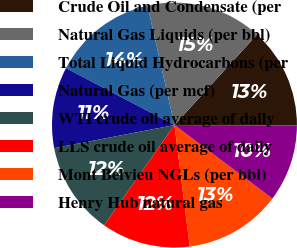<chart> <loc_0><loc_0><loc_500><loc_500><pie_chart><fcel>Crude Oil and Condensate (per<fcel>Natural Gas Liquids (per bbl)<fcel>Total Liquid Hydrocarbons (per<fcel>Natural Gas (per mcf)<fcel>WTI crude oil average of daily<fcel>LLS crude oil average of daily<fcel>Mont Belvieu NGLs (per bbl)<fcel>Henry Hub natural gas<nl><fcel>13.27%<fcel>15.31%<fcel>13.78%<fcel>10.71%<fcel>12.24%<fcel>11.73%<fcel>12.76%<fcel>10.2%<nl></chart> 